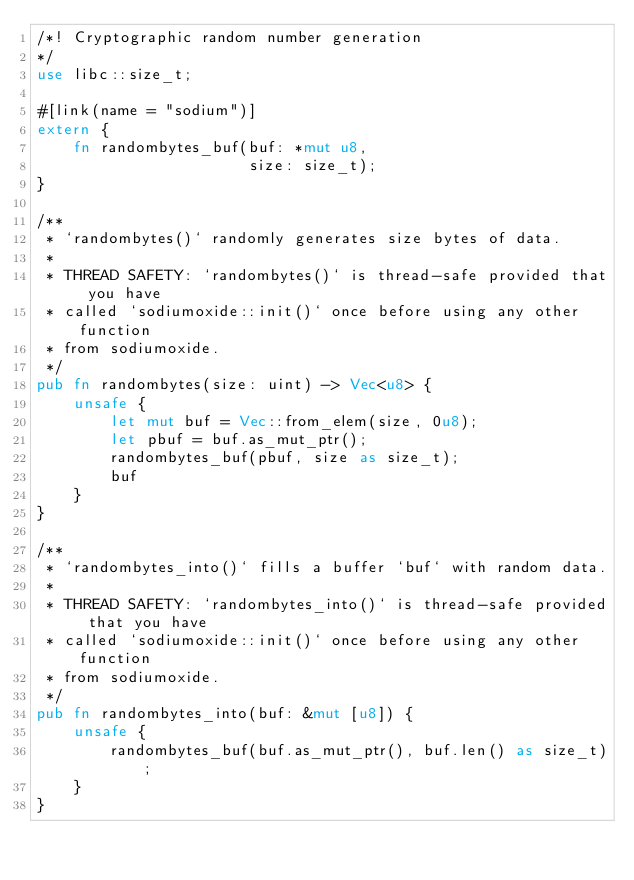<code> <loc_0><loc_0><loc_500><loc_500><_Rust_>/*! Cryptographic random number generation
*/
use libc::size_t;

#[link(name = "sodium")]
extern {
    fn randombytes_buf(buf: *mut u8,
                       size: size_t);
}

/**
 * `randombytes()` randomly generates size bytes of data.
 *
 * THREAD SAFETY: `randombytes()` is thread-safe provided that you have
 * called `sodiumoxide::init()` once before using any other function
 * from sodiumoxide.
 */
pub fn randombytes(size: uint) -> Vec<u8> {
    unsafe {
        let mut buf = Vec::from_elem(size, 0u8);
        let pbuf = buf.as_mut_ptr();
        randombytes_buf(pbuf, size as size_t);
        buf
    }
}

/**
 * `randombytes_into()` fills a buffer `buf` with random data.
 *
 * THREAD SAFETY: `randombytes_into()` is thread-safe provided that you have
 * called `sodiumoxide::init()` once before using any other function
 * from sodiumoxide.
 */
pub fn randombytes_into(buf: &mut [u8]) {
    unsafe {
        randombytes_buf(buf.as_mut_ptr(), buf.len() as size_t);
    }
}
</code> 